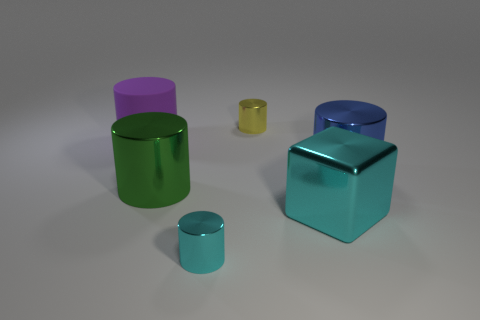Subtract all purple cylinders. How many cylinders are left? 4 Subtract all brown cylinders. Subtract all green spheres. How many cylinders are left? 5 Add 3 big things. How many objects exist? 9 Subtract all cubes. How many objects are left? 5 Subtract all cyan metal cylinders. Subtract all cyan shiny objects. How many objects are left? 3 Add 4 green shiny cylinders. How many green shiny cylinders are left? 5 Add 1 small yellow metal balls. How many small yellow metal balls exist? 1 Subtract 0 brown spheres. How many objects are left? 6 